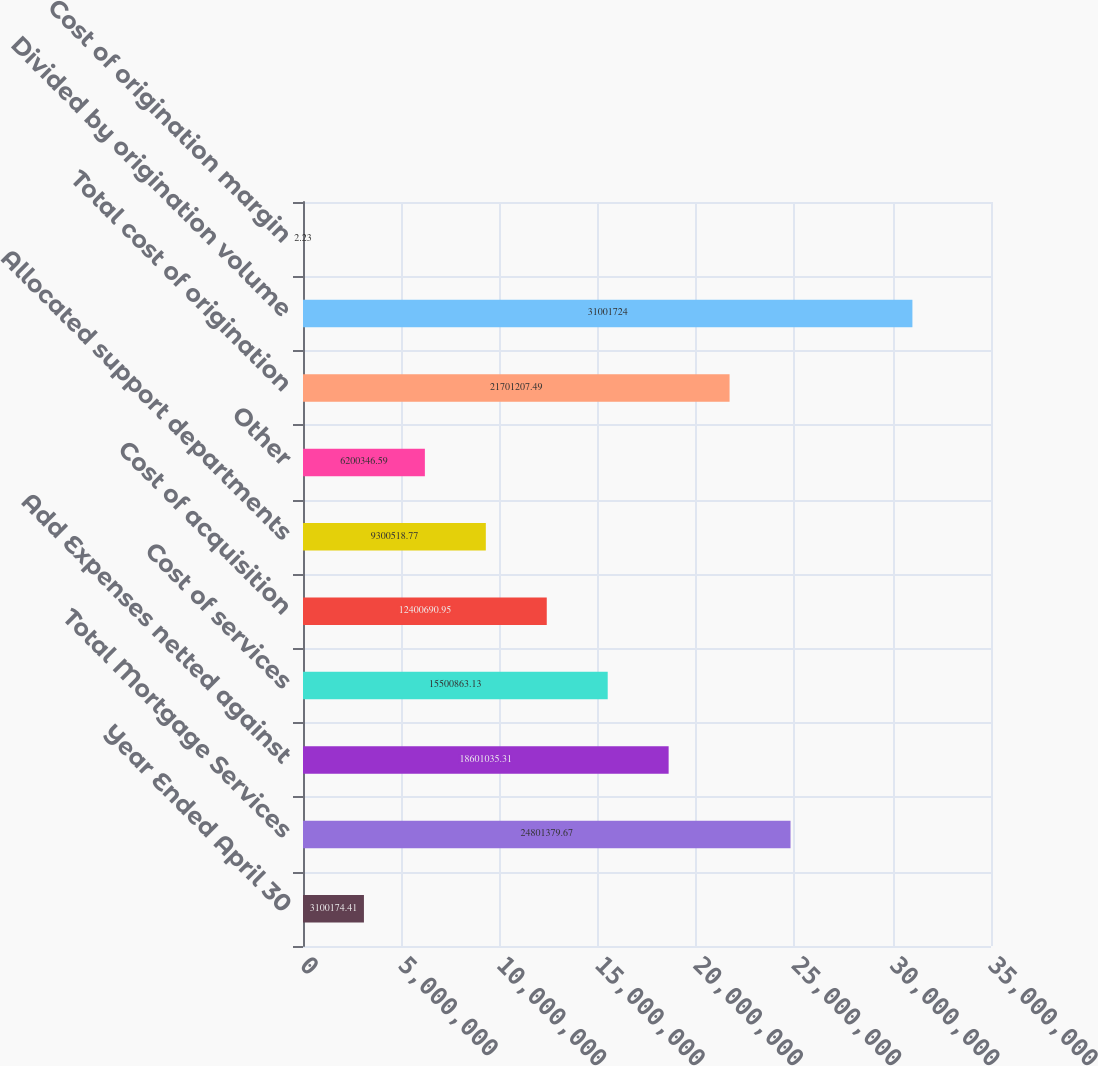Convert chart to OTSL. <chart><loc_0><loc_0><loc_500><loc_500><bar_chart><fcel>Year Ended April 30<fcel>Total Mortgage Services<fcel>Add Expenses netted against<fcel>Cost of services<fcel>Cost of acquisition<fcel>Allocated support departments<fcel>Other<fcel>Total cost of origination<fcel>Divided by origination volume<fcel>Cost of origination margin<nl><fcel>3.10017e+06<fcel>2.48014e+07<fcel>1.8601e+07<fcel>1.55009e+07<fcel>1.24007e+07<fcel>9.30052e+06<fcel>6.20035e+06<fcel>2.17012e+07<fcel>3.10017e+07<fcel>2.23<nl></chart> 